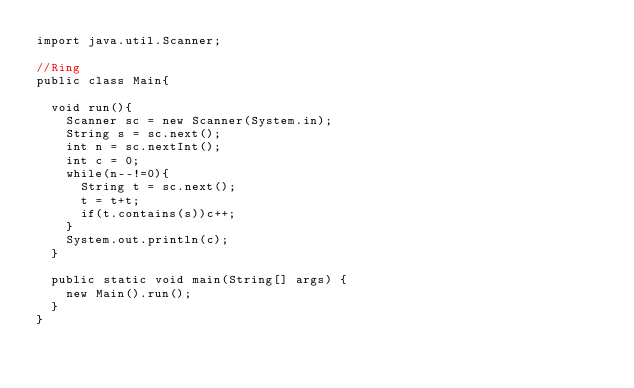<code> <loc_0><loc_0><loc_500><loc_500><_Java_>import java.util.Scanner;

//Ring
public class Main{

	void run(){
		Scanner sc = new Scanner(System.in);
		String s = sc.next();
		int n = sc.nextInt();
		int c = 0;
		while(n--!=0){
			String t = sc.next();
			t = t+t;
			if(t.contains(s))c++;
		}
		System.out.println(c);
	}
	
	public static void main(String[] args) {
		new Main().run();
	}
}</code> 